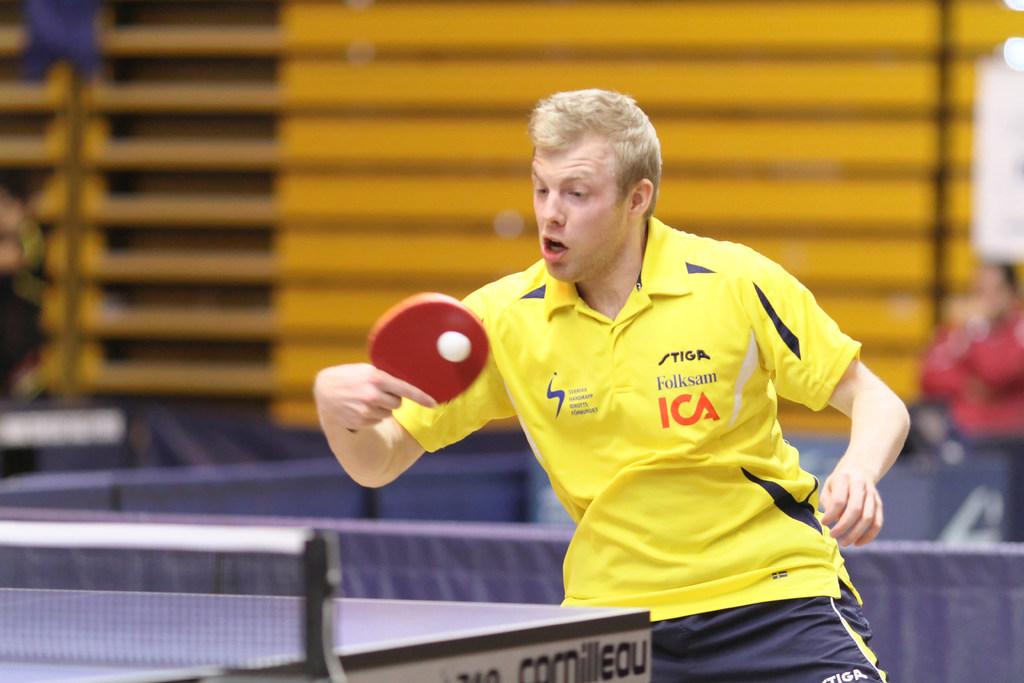What are some of the companies that sponsor this ping pong player?
Keep it short and to the point. Ica. Who is the mans sponsor?
Offer a terse response. Ica. 